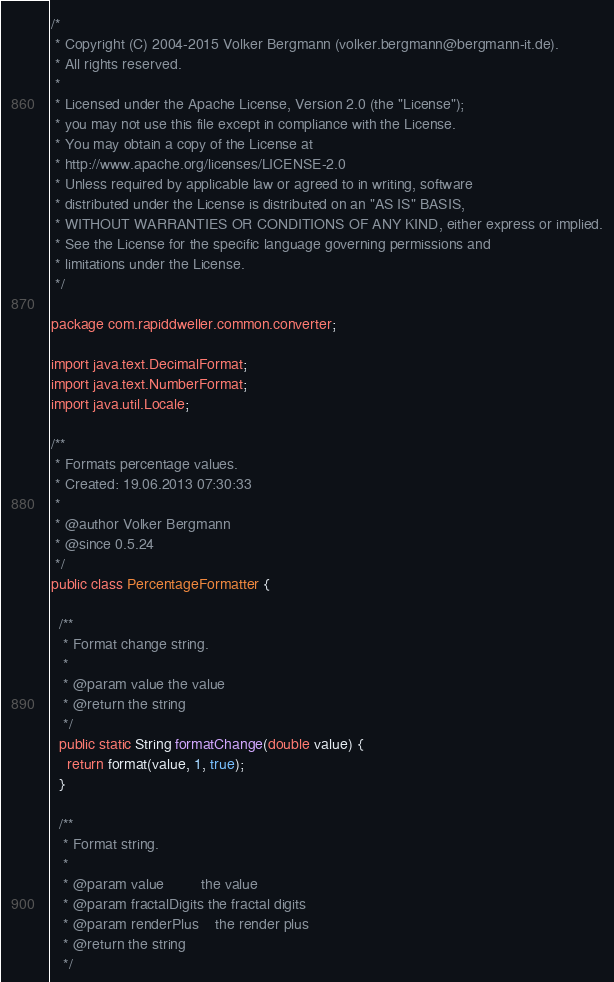<code> <loc_0><loc_0><loc_500><loc_500><_Java_>/*
 * Copyright (C) 2004-2015 Volker Bergmann (volker.bergmann@bergmann-it.de).
 * All rights reserved.
 *
 * Licensed under the Apache License, Version 2.0 (the "License");
 * you may not use this file except in compliance with the License.
 * You may obtain a copy of the License at
 * http://www.apache.org/licenses/LICENSE-2.0
 * Unless required by applicable law or agreed to in writing, software
 * distributed under the License is distributed on an "AS IS" BASIS,
 * WITHOUT WARRANTIES OR CONDITIONS OF ANY KIND, either express or implied.
 * See the License for the specific language governing permissions and
 * limitations under the License.
 */

package com.rapiddweller.common.converter;

import java.text.DecimalFormat;
import java.text.NumberFormat;
import java.util.Locale;

/**
 * Formats percentage values.
 * Created: 19.06.2013 07:30:33
 *
 * @author Volker Bergmann
 * @since 0.5.24
 */
public class PercentageFormatter {

  /**
   * Format change string.
   *
   * @param value the value
   * @return the string
   */
  public static String formatChange(double value) {
    return format(value, 1, true);
  }

  /**
   * Format string.
   *
   * @param value         the value
   * @param fractalDigits the fractal digits
   * @param renderPlus    the render plus
   * @return the string
   */</code> 